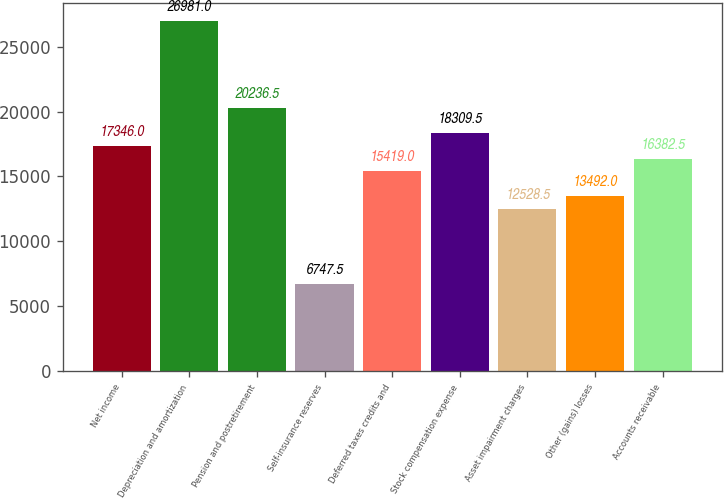<chart> <loc_0><loc_0><loc_500><loc_500><bar_chart><fcel>Net income<fcel>Depreciation and amortization<fcel>Pension and postretirement<fcel>Self-insurance reserves<fcel>Deferred taxes credits and<fcel>Stock compensation expense<fcel>Asset impairment charges<fcel>Other (gains) losses<fcel>Accounts receivable<nl><fcel>17346<fcel>26981<fcel>20236.5<fcel>6747.5<fcel>15419<fcel>18309.5<fcel>12528.5<fcel>13492<fcel>16382.5<nl></chart> 